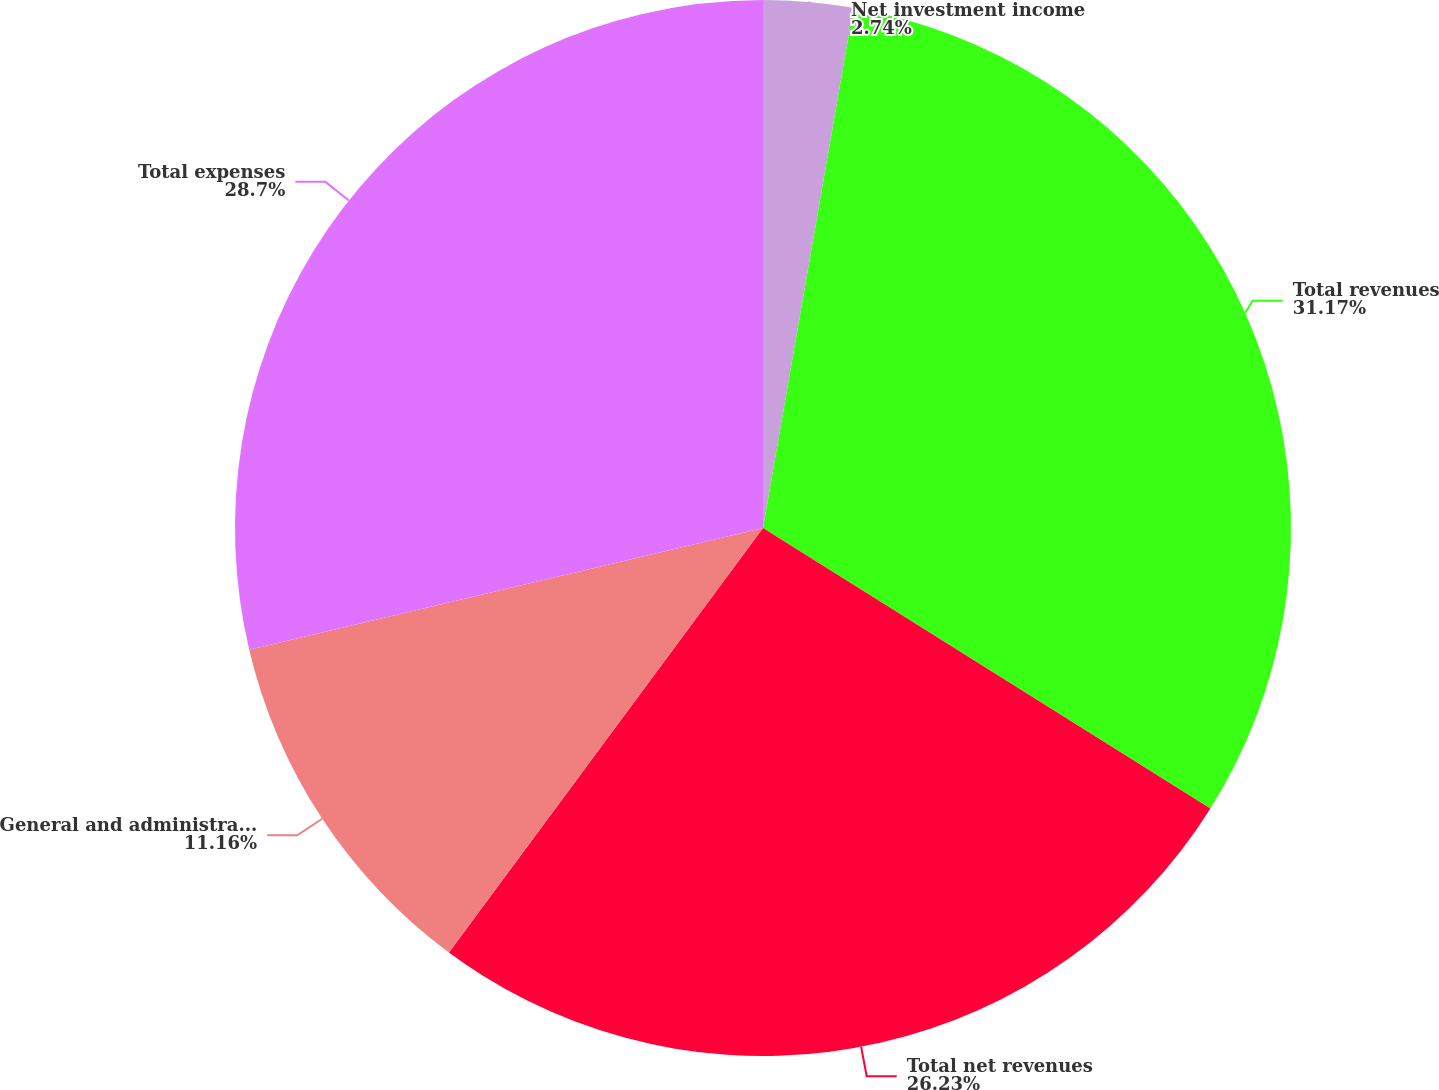Convert chart. <chart><loc_0><loc_0><loc_500><loc_500><pie_chart><fcel>Net investment income<fcel>Total revenues<fcel>Total net revenues<fcel>General and administrative<fcel>Total expenses<nl><fcel>2.74%<fcel>31.17%<fcel>26.23%<fcel>11.16%<fcel>28.7%<nl></chart> 